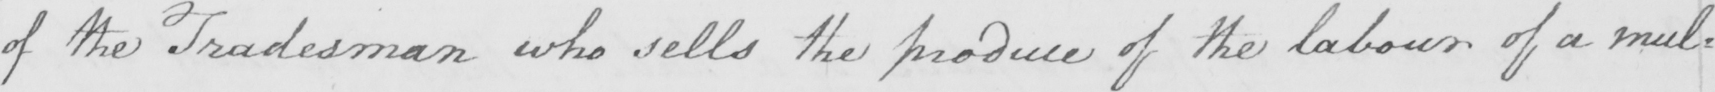What is written in this line of handwriting? of the Tradesman who sells the produce of the labour of a mul= 